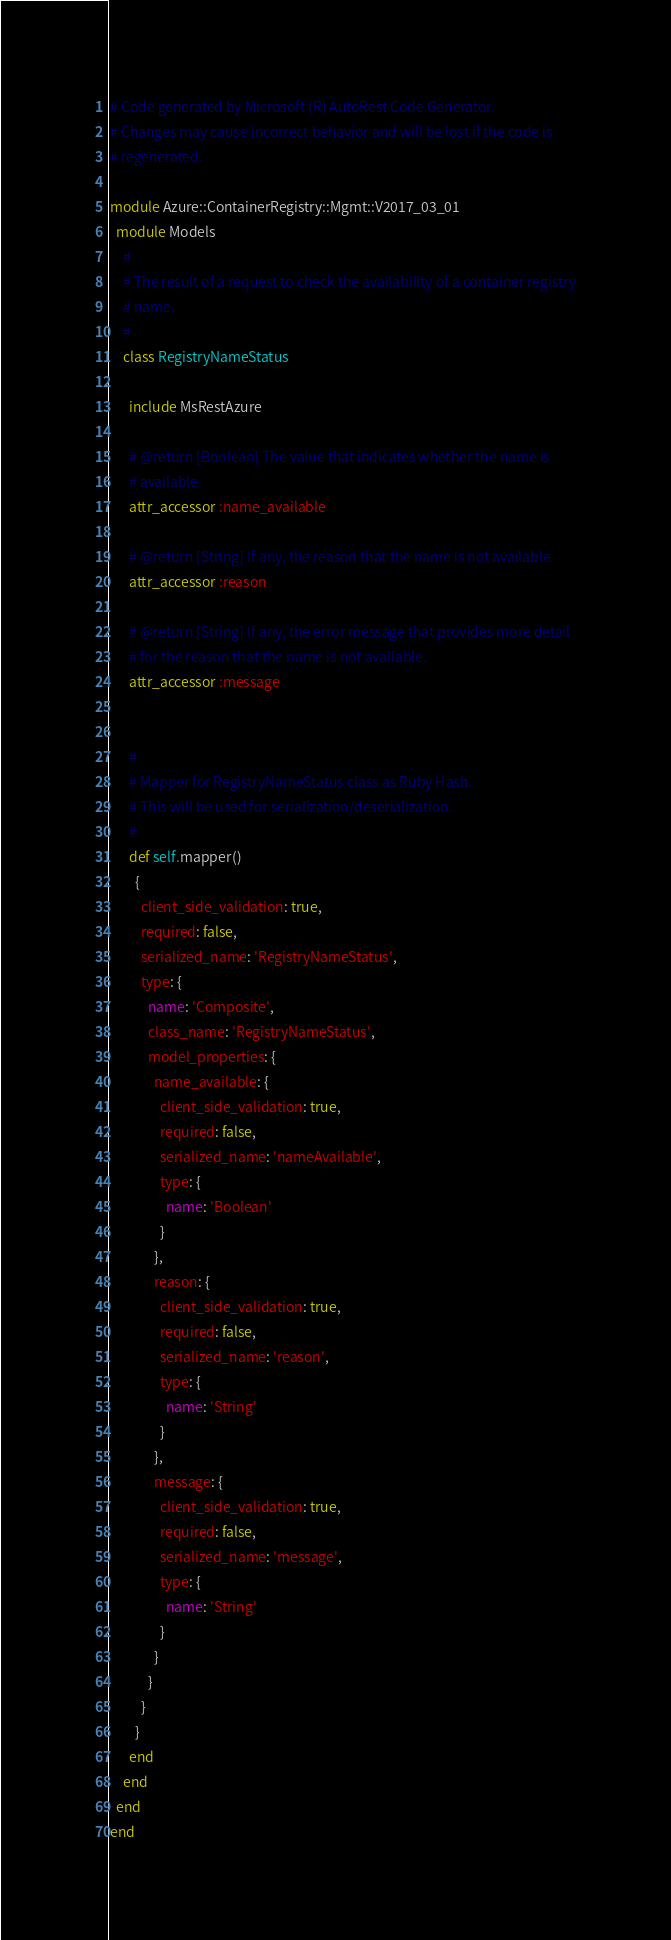<code> <loc_0><loc_0><loc_500><loc_500><_Ruby_># Code generated by Microsoft (R) AutoRest Code Generator.
# Changes may cause incorrect behavior and will be lost if the code is
# regenerated.

module Azure::ContainerRegistry::Mgmt::V2017_03_01
  module Models
    #
    # The result of a request to check the availability of a container registry
    # name.
    #
    class RegistryNameStatus

      include MsRestAzure

      # @return [Boolean] The value that indicates whether the name is
      # available.
      attr_accessor :name_available

      # @return [String] If any, the reason that the name is not available.
      attr_accessor :reason

      # @return [String] If any, the error message that provides more detail
      # for the reason that the name is not available.
      attr_accessor :message


      #
      # Mapper for RegistryNameStatus class as Ruby Hash.
      # This will be used for serialization/deserialization.
      #
      def self.mapper()
        {
          client_side_validation: true,
          required: false,
          serialized_name: 'RegistryNameStatus',
          type: {
            name: 'Composite',
            class_name: 'RegistryNameStatus',
            model_properties: {
              name_available: {
                client_side_validation: true,
                required: false,
                serialized_name: 'nameAvailable',
                type: {
                  name: 'Boolean'
                }
              },
              reason: {
                client_side_validation: true,
                required: false,
                serialized_name: 'reason',
                type: {
                  name: 'String'
                }
              },
              message: {
                client_side_validation: true,
                required: false,
                serialized_name: 'message',
                type: {
                  name: 'String'
                }
              }
            }
          }
        }
      end
    end
  end
end
</code> 